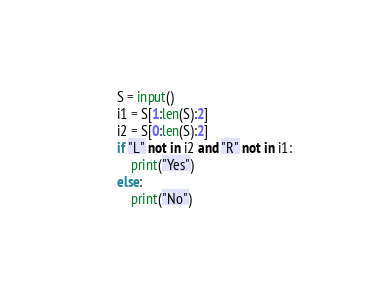<code> <loc_0><loc_0><loc_500><loc_500><_Python_>S = input()
i1 = S[1:len(S):2]
i2 = S[0:len(S):2]
if "L" not in i2 and "R" not in i1:
    print("Yes")
else:
    print("No")</code> 